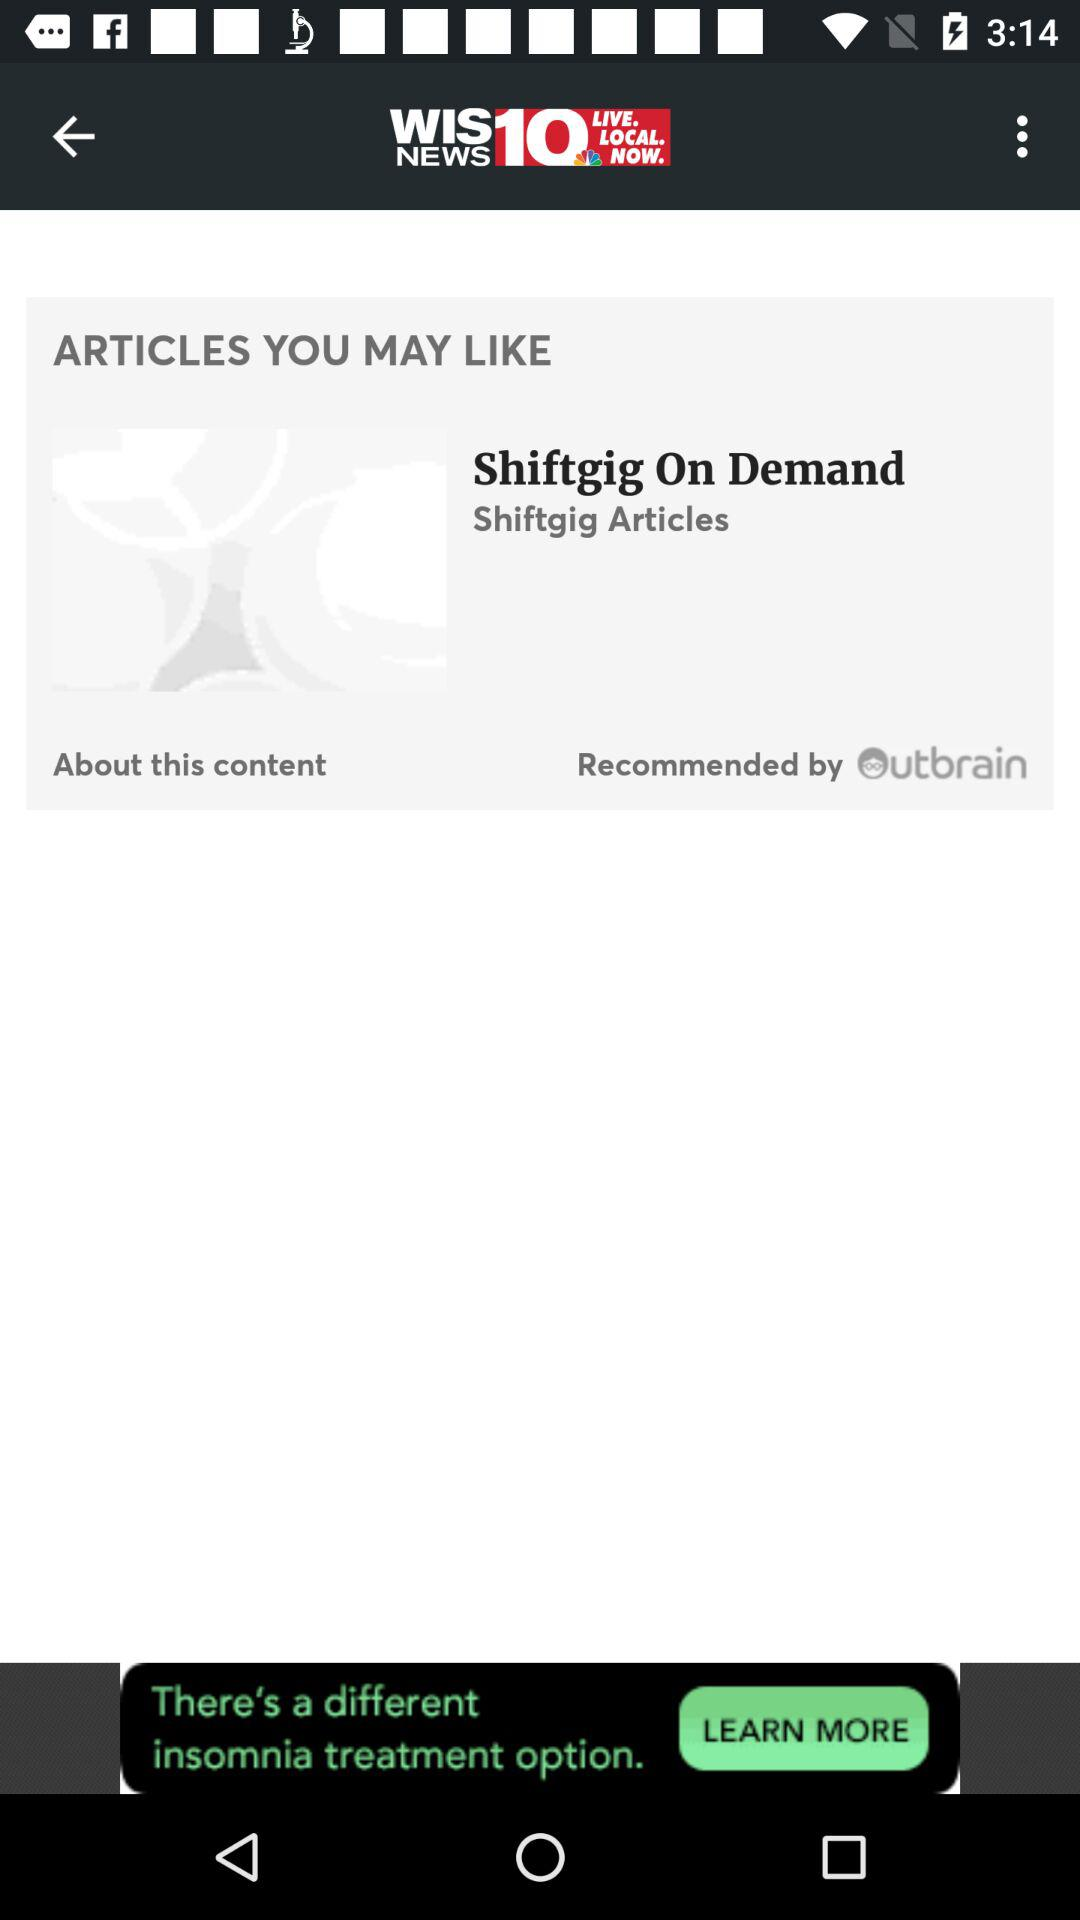What is the name of the application? The application name is "WIS NEWS". 